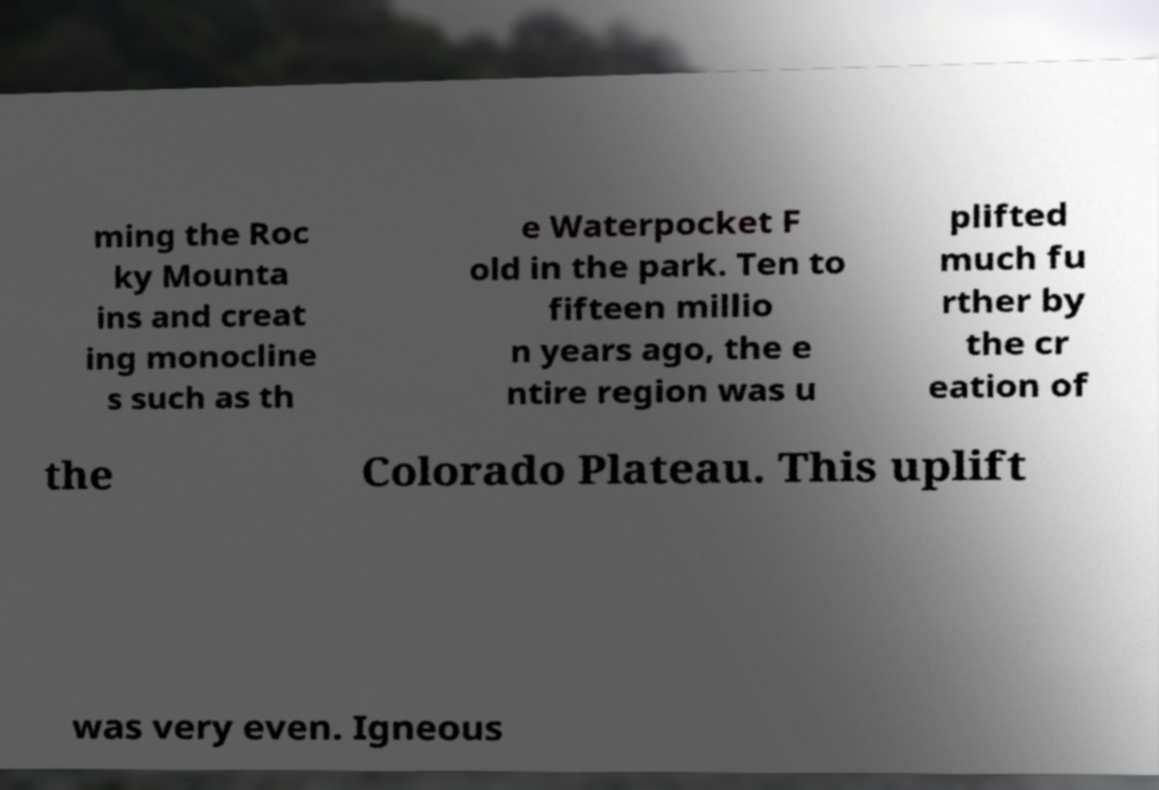Can you read and provide the text displayed in the image?This photo seems to have some interesting text. Can you extract and type it out for me? ming the Roc ky Mounta ins and creat ing monocline s such as th e Waterpocket F old in the park. Ten to fifteen millio n years ago, the e ntire region was u plifted much fu rther by the cr eation of the Colorado Plateau. This uplift was very even. Igneous 